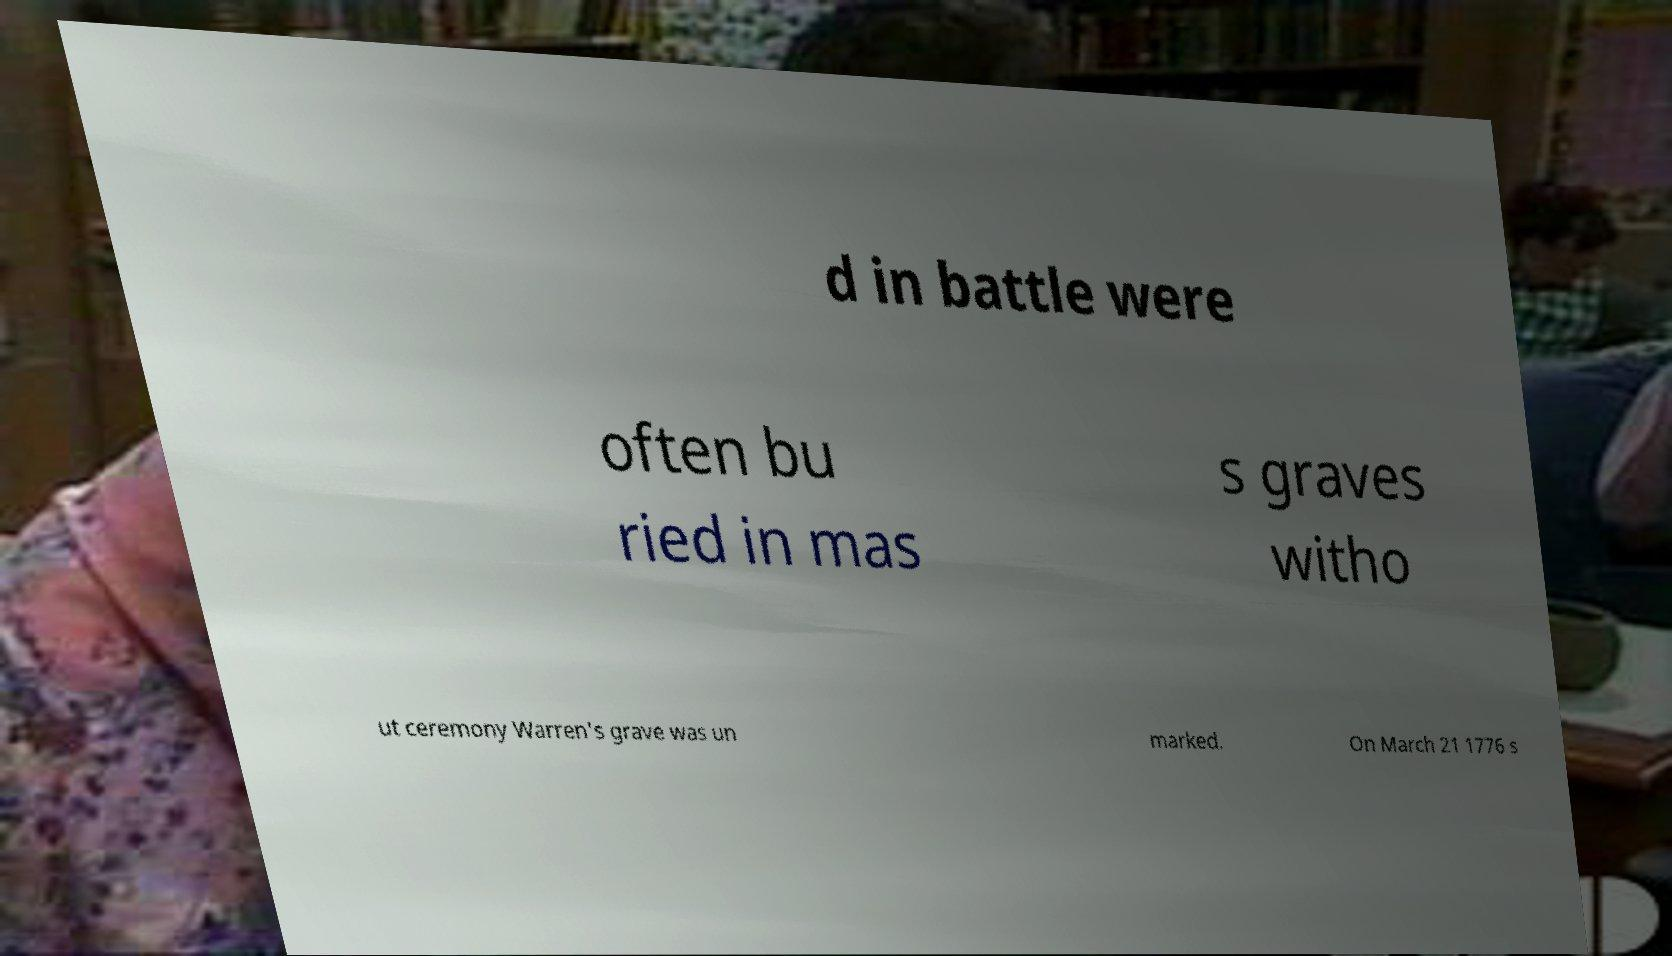For documentation purposes, I need the text within this image transcribed. Could you provide that? d in battle were often bu ried in mas s graves witho ut ceremony Warren's grave was un marked. On March 21 1776 s 